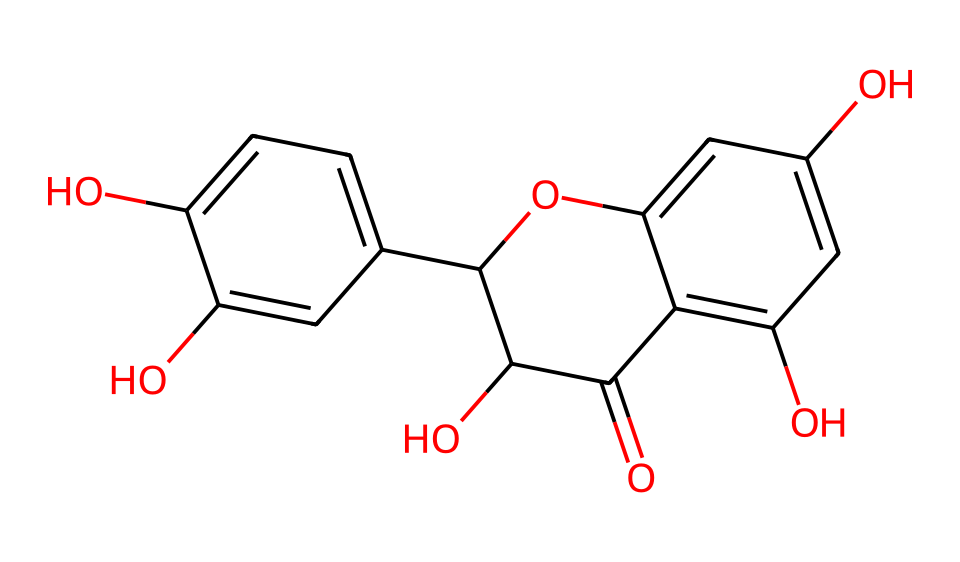How many hydroxyl (–OH) groups are present in quercetin? By examining the structure, we identify the positions on the aromatic rings where hydroxyl groups are attached. In the structural representation, there are four distinct –OH groups visible. Each is indicated by a hydroxyl functional group directly connected to the aromatic carbons.
Answer: four What type of chemical bonding predominates in quercetin's structure? The primary type of bonding in quercetin is covalent bonding. This is concluded by noting that carbon and oxygen atoms form stable connections with shared electron pairs, especially seen in the hydroxyl groups and the rings in the structure.
Answer: covalent What is the molecular formula of quercetin? To find the molecular formula, we count atoms from the visual representation: there are 15 carbons, 10 hydrogens, and 7 oxygens (C15H10O7). This can be confirmed by tallying each atom type from the SMILES representation.
Answer: C15H10O7 Which functional groups can be identified in quercetin? The structure features several functional groups, notably hydroxyl (–OH) groups and a ketone (C=O) group. The presence of multiple hydroxyl groups is typical of flavonoids, contributing to their antioxidant properties.
Answer: hydroxyl, ketone What structural feature of quercetin contributes to its antioxidant activity? The presence of multiple hydroxyl groups is crucial as they can donate hydrogen atoms and scavenge free radicals, which is characteristic of antioxidants. The specific arrangement facilitates electron transfer, enhancing its activity.
Answer: hydroxyl groups How many rings are present in the quercetin structure? The chemical structure of quercetin showcases three interconnected rings which can be observed as distinct cyclic structures. Two of these rings are part of the flavonoid backbone.
Answer: three 